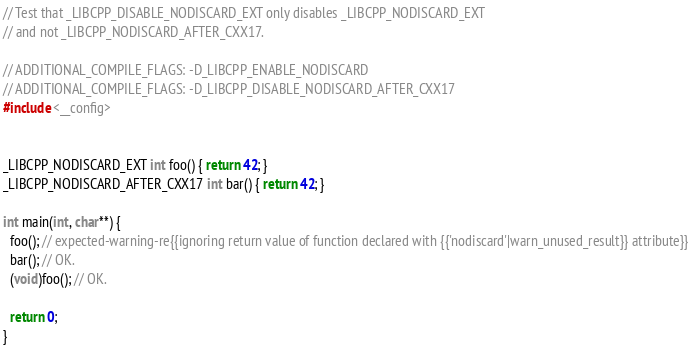Convert code to text. <code><loc_0><loc_0><loc_500><loc_500><_C++_>
// Test that _LIBCPP_DISABLE_NODISCARD_EXT only disables _LIBCPP_NODISCARD_EXT
// and not _LIBCPP_NODISCARD_AFTER_CXX17.

// ADDITIONAL_COMPILE_FLAGS: -D_LIBCPP_ENABLE_NODISCARD
// ADDITIONAL_COMPILE_FLAGS: -D_LIBCPP_DISABLE_NODISCARD_AFTER_CXX17
#include <__config>


_LIBCPP_NODISCARD_EXT int foo() { return 42; }
_LIBCPP_NODISCARD_AFTER_CXX17 int bar() { return 42; }

int main(int, char**) {
  foo(); // expected-warning-re{{ignoring return value of function declared with {{'nodiscard'|warn_unused_result}} attribute}}
  bar(); // OK.
  (void)foo(); // OK.

  return 0;
}
</code> 